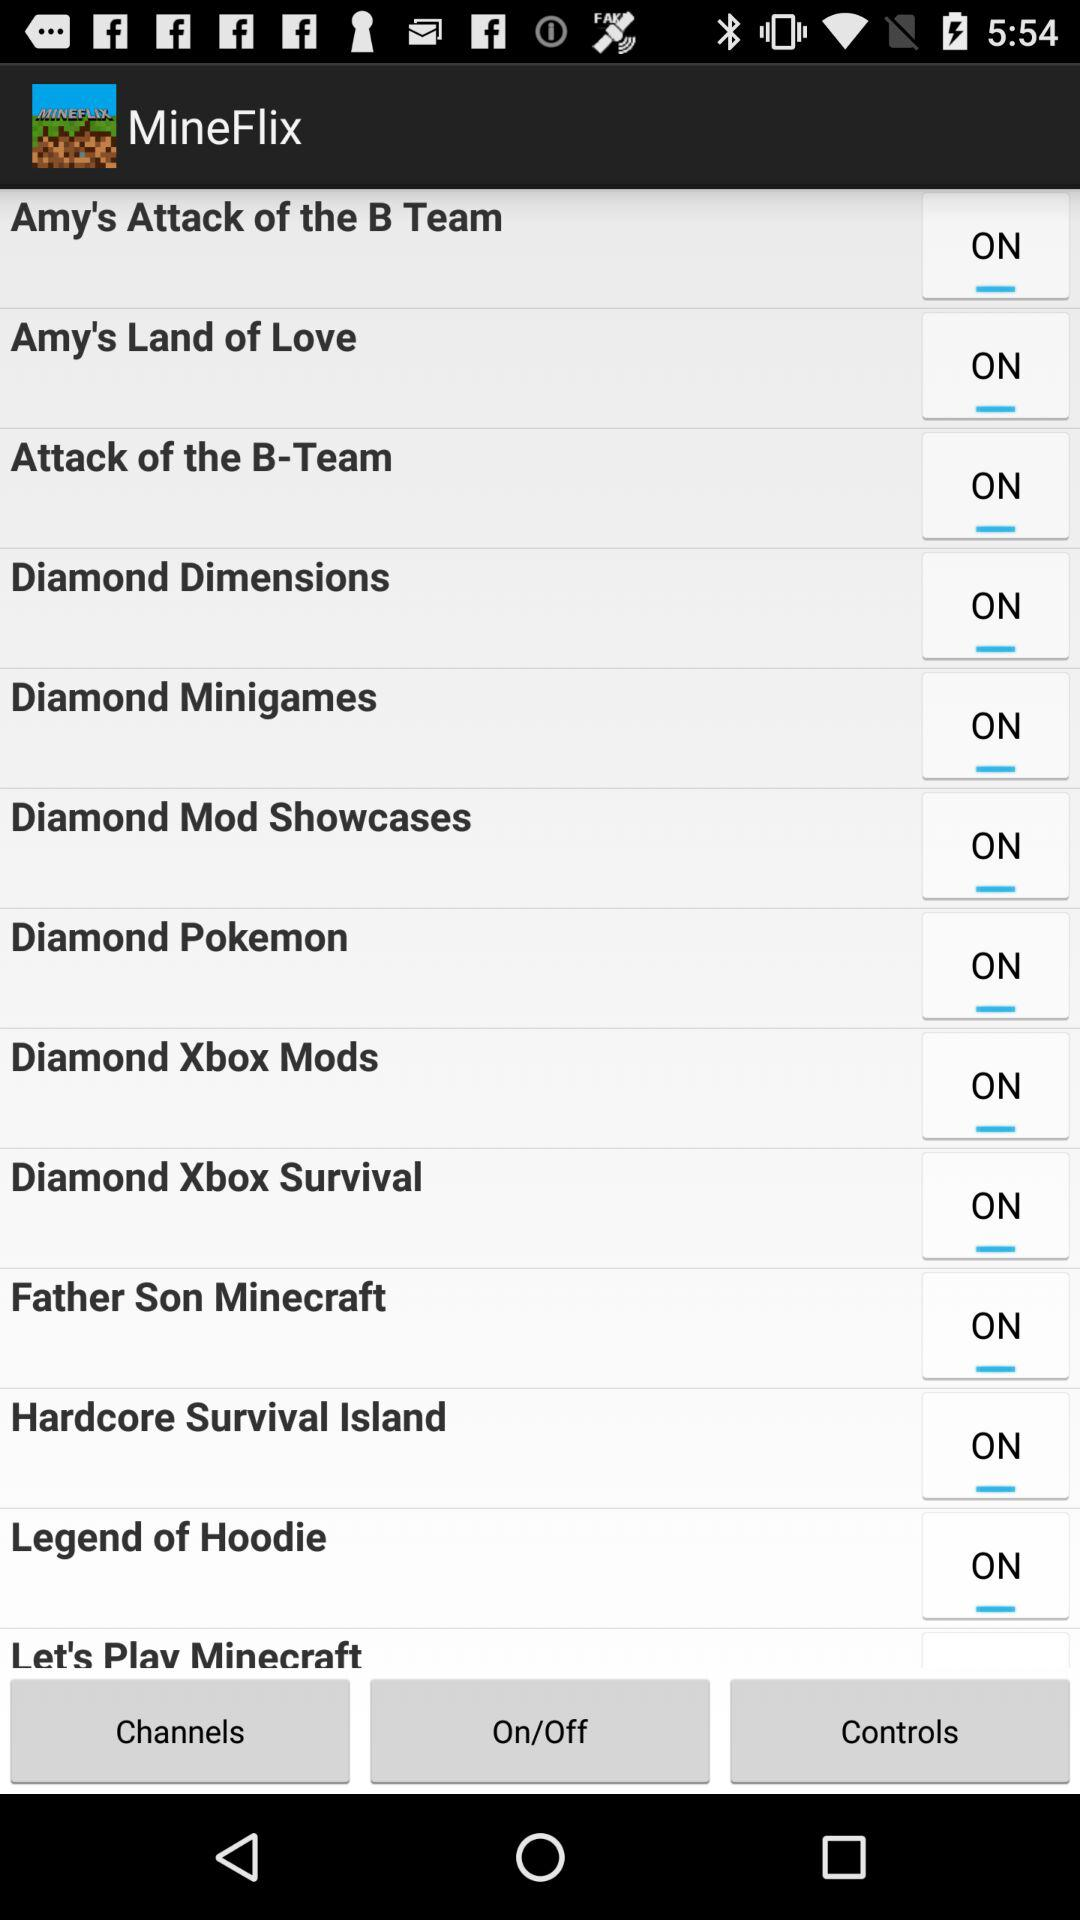What is the status of "Legend of Hoodie"? The status of "Legend of Hoodie" is "on". 